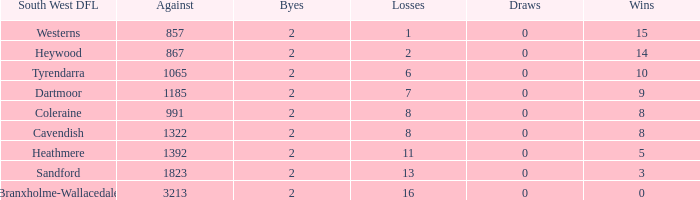With 16 losses and an against figure below 3213, how many wins are there? None. 